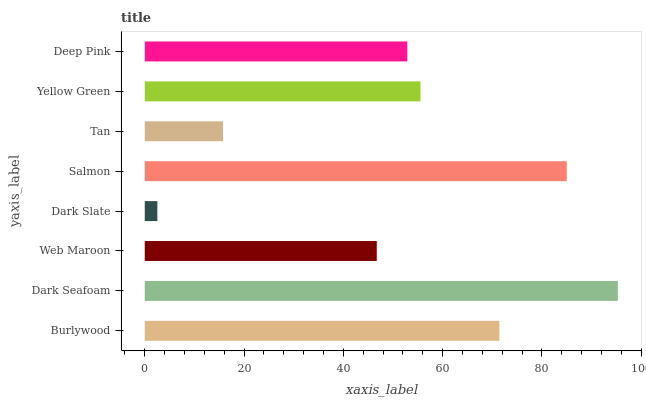Is Dark Slate the minimum?
Answer yes or no. Yes. Is Dark Seafoam the maximum?
Answer yes or no. Yes. Is Web Maroon the minimum?
Answer yes or no. No. Is Web Maroon the maximum?
Answer yes or no. No. Is Dark Seafoam greater than Web Maroon?
Answer yes or no. Yes. Is Web Maroon less than Dark Seafoam?
Answer yes or no. Yes. Is Web Maroon greater than Dark Seafoam?
Answer yes or no. No. Is Dark Seafoam less than Web Maroon?
Answer yes or no. No. Is Yellow Green the high median?
Answer yes or no. Yes. Is Deep Pink the low median?
Answer yes or no. Yes. Is Tan the high median?
Answer yes or no. No. Is Dark Slate the low median?
Answer yes or no. No. 